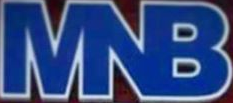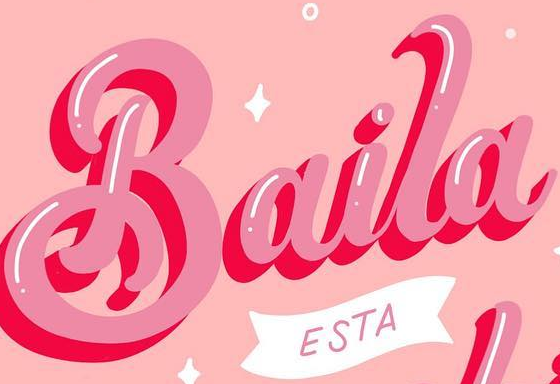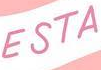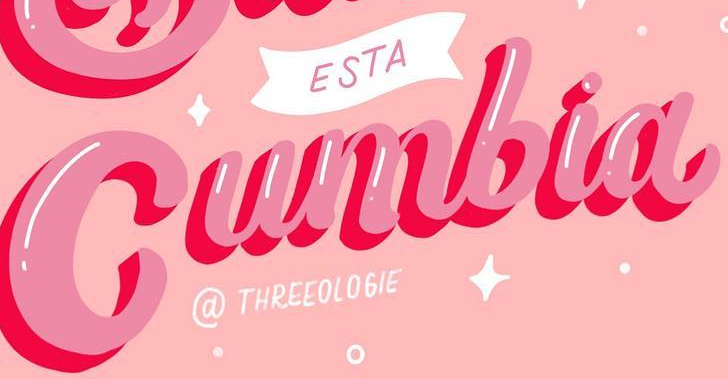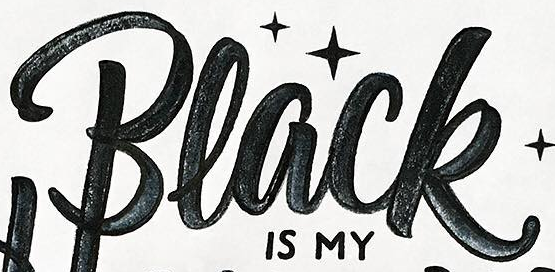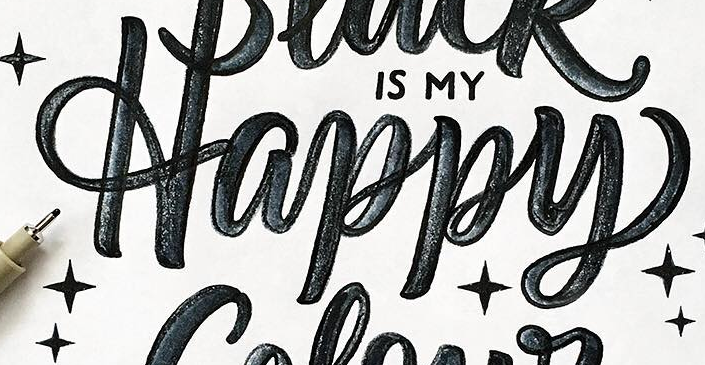What text appears in these images from left to right, separated by a semicolon? MNB; Baila; ESTA; Cumbia; Black; Happy 